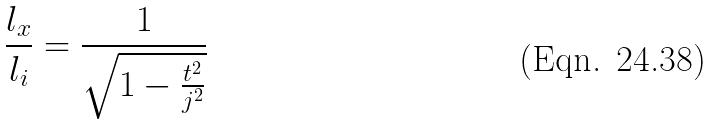<formula> <loc_0><loc_0><loc_500><loc_500>\frac { l _ { x } } { l _ { i } } = \frac { 1 } { \sqrt { 1 - \frac { t ^ { 2 } } { j ^ { 2 } } } }</formula> 